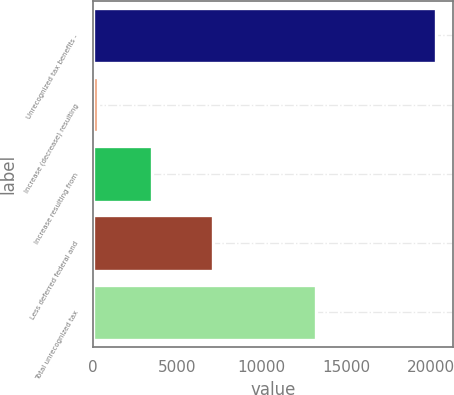<chart> <loc_0><loc_0><loc_500><loc_500><bar_chart><fcel>Unrecognized tax benefits -<fcel>Increase (decrease) resulting<fcel>Increase resulting from<fcel>Less deferred federal and<fcel>Total unrecognized tax<nl><fcel>20298<fcel>290<fcel>3519<fcel>7104<fcel>13194<nl></chart> 